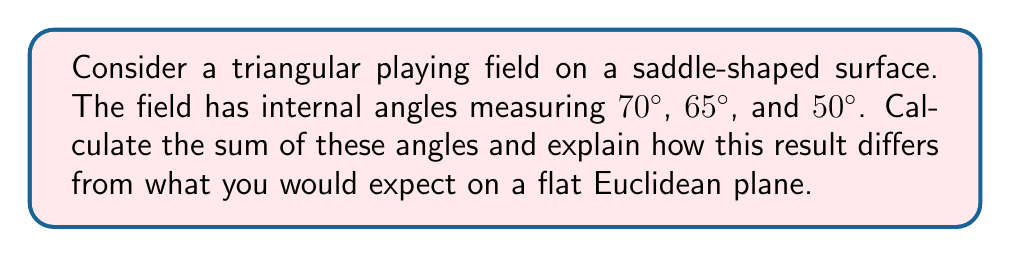Can you answer this question? Let's approach this step-by-step:

1) First, let's recall the theorem for the sum of angles in a triangle:
   - On a flat (Euclidean) plane: The sum is always 180°
   - On a saddle-shaped (hyperbolic) surface: The sum is always less than 180°

2) Calculate the sum of the given angles:
   $$70° + 65° + 50° = 185°$$

3) This result (185°) is greater than 180°, which is unexpected for both Euclidean and hyperbolic geometry.

4) The fact that the sum exceeds 180° indicates that this triangle is on a surface with positive curvature (like a sphere) rather than negative curvature (like a saddle).

5) In elliptic geometry (positive curvature):
   $$\text{Sum of angles} = 180° + \alpha$$
   where $\alpha$ is proportional to the area of the triangle and the curvature of the surface.

6) In this case:
   $$185° = 180° + 5°$$
   So, $\alpha = 5°$

7) This excess of 5° is a measure of how much the surface curves over the area of the triangle.

[asy]
import geometry;

size(200);
pair A=(0,0), B=(2,0), C=(1,1.5);
draw(A--B--C--cycle);
label("70°", A, SW);
label("65°", B, SE);
label("50°", C, N);
label("Curved surface", (1,-0.5));
[/asy]
Answer: 185°; exceeds 180°, indicating positive curvature 